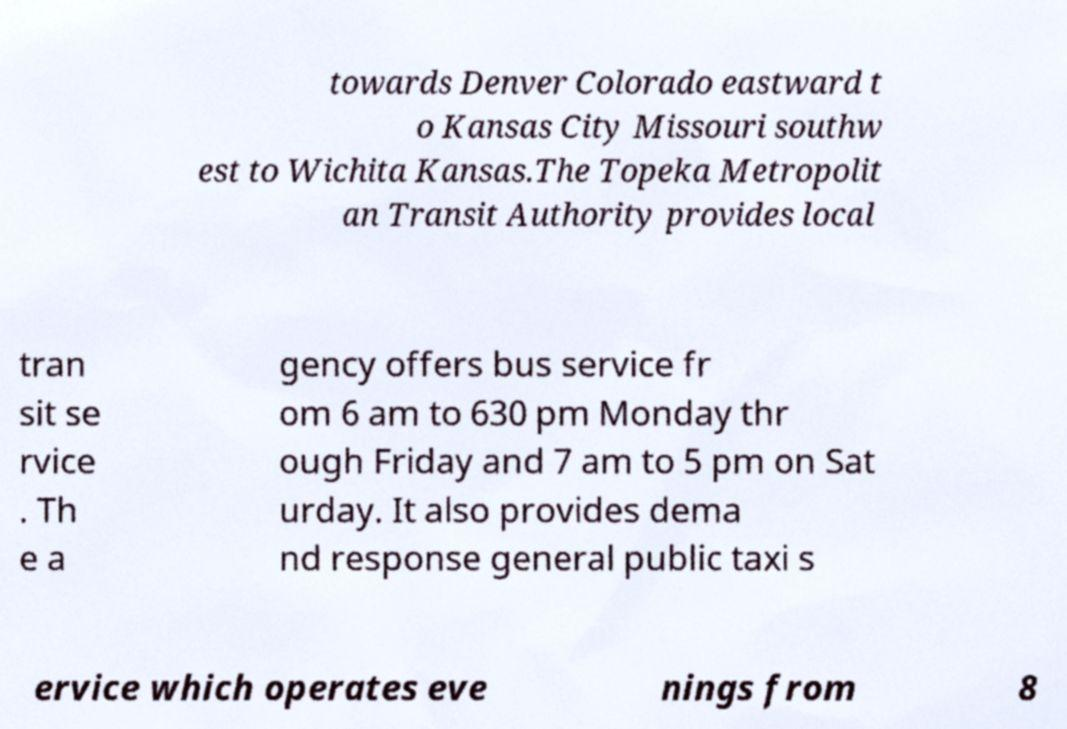I need the written content from this picture converted into text. Can you do that? towards Denver Colorado eastward t o Kansas City Missouri southw est to Wichita Kansas.The Topeka Metropolit an Transit Authority provides local tran sit se rvice . Th e a gency offers bus service fr om 6 am to 630 pm Monday thr ough Friday and 7 am to 5 pm on Sat urday. It also provides dema nd response general public taxi s ervice which operates eve nings from 8 